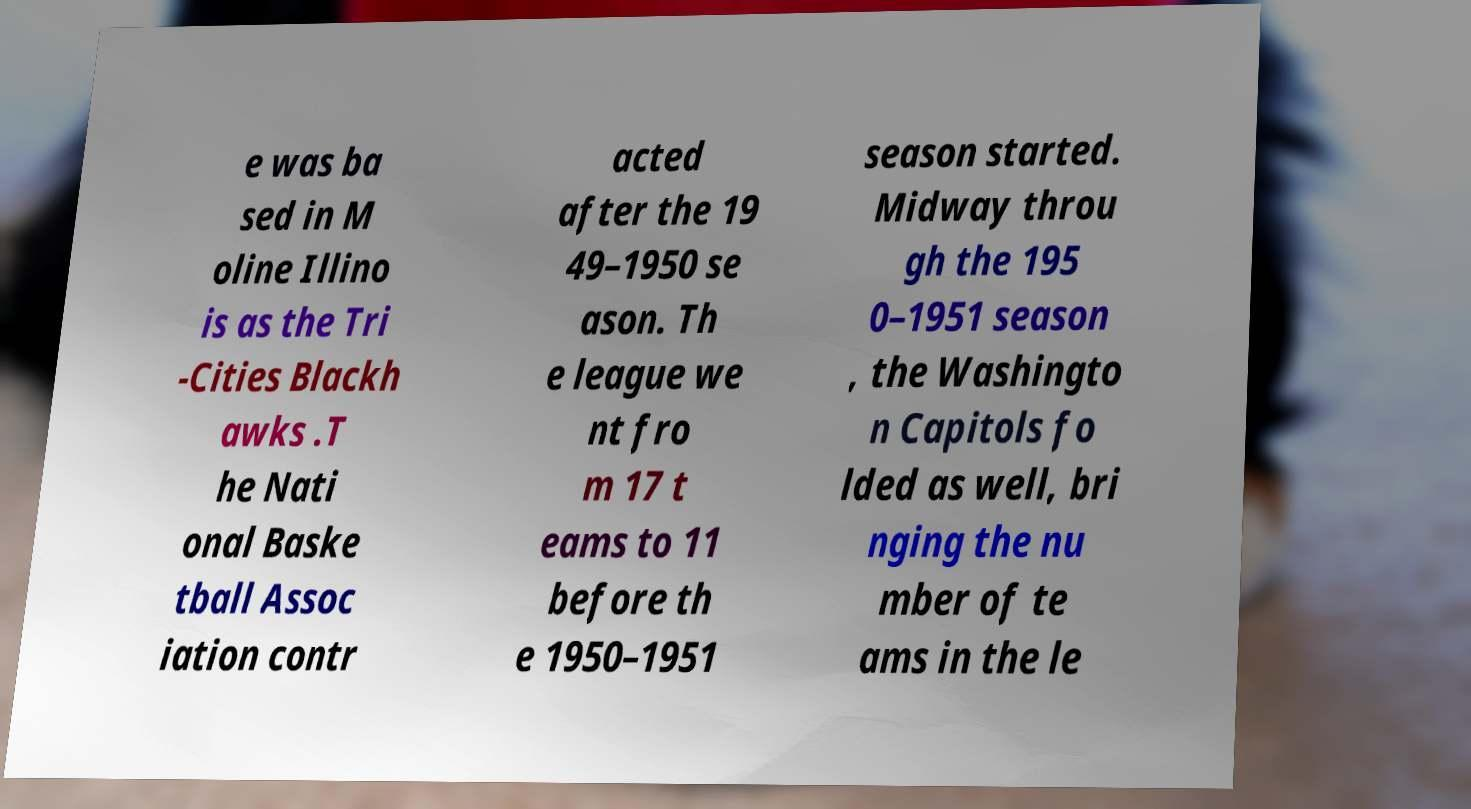Can you accurately transcribe the text from the provided image for me? e was ba sed in M oline Illino is as the Tri -Cities Blackh awks .T he Nati onal Baske tball Assoc iation contr acted after the 19 49–1950 se ason. Th e league we nt fro m 17 t eams to 11 before th e 1950–1951 season started. Midway throu gh the 195 0–1951 season , the Washingto n Capitols fo lded as well, bri nging the nu mber of te ams in the le 